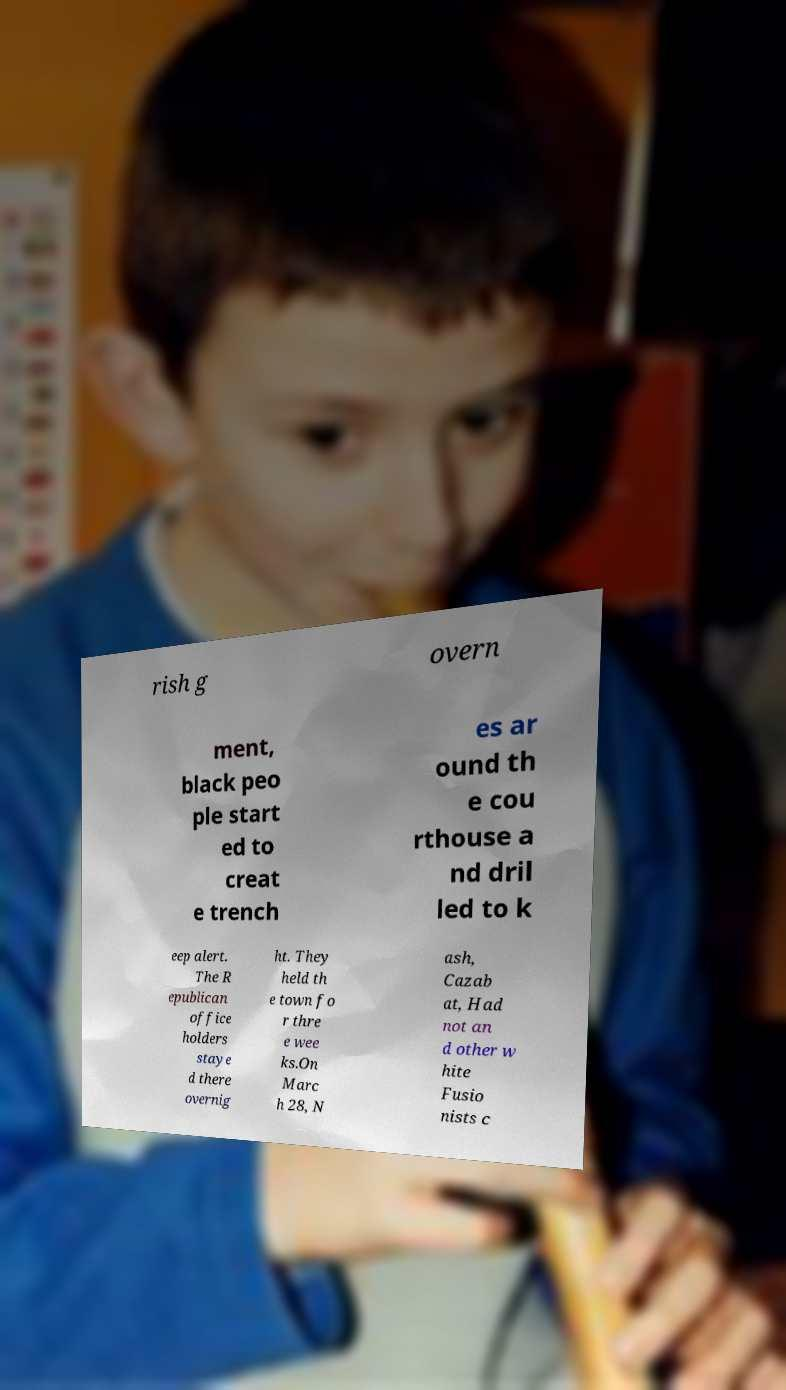Please read and relay the text visible in this image. What does it say? rish g overn ment, black peo ple start ed to creat e trench es ar ound th e cou rthouse a nd dril led to k eep alert. The R epublican office holders staye d there overnig ht. They held th e town fo r thre e wee ks.On Marc h 28, N ash, Cazab at, Had not an d other w hite Fusio nists c 